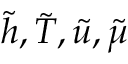Convert formula to latex. <formula><loc_0><loc_0><loc_500><loc_500>{ \tilde { h } } , { \tilde { T } } , { \tilde { u } } , { \tilde { \mu } }</formula> 